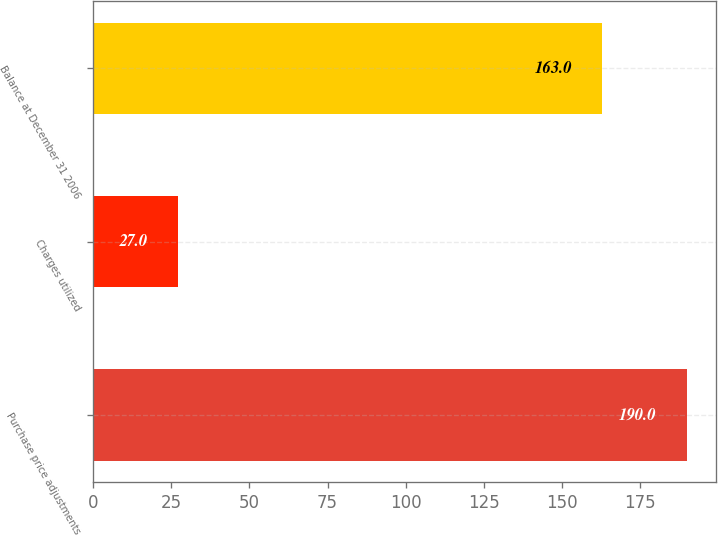Convert chart. <chart><loc_0><loc_0><loc_500><loc_500><bar_chart><fcel>Purchase price adjustments<fcel>Charges utilized<fcel>Balance at December 31 2006<nl><fcel>190<fcel>27<fcel>163<nl></chart> 